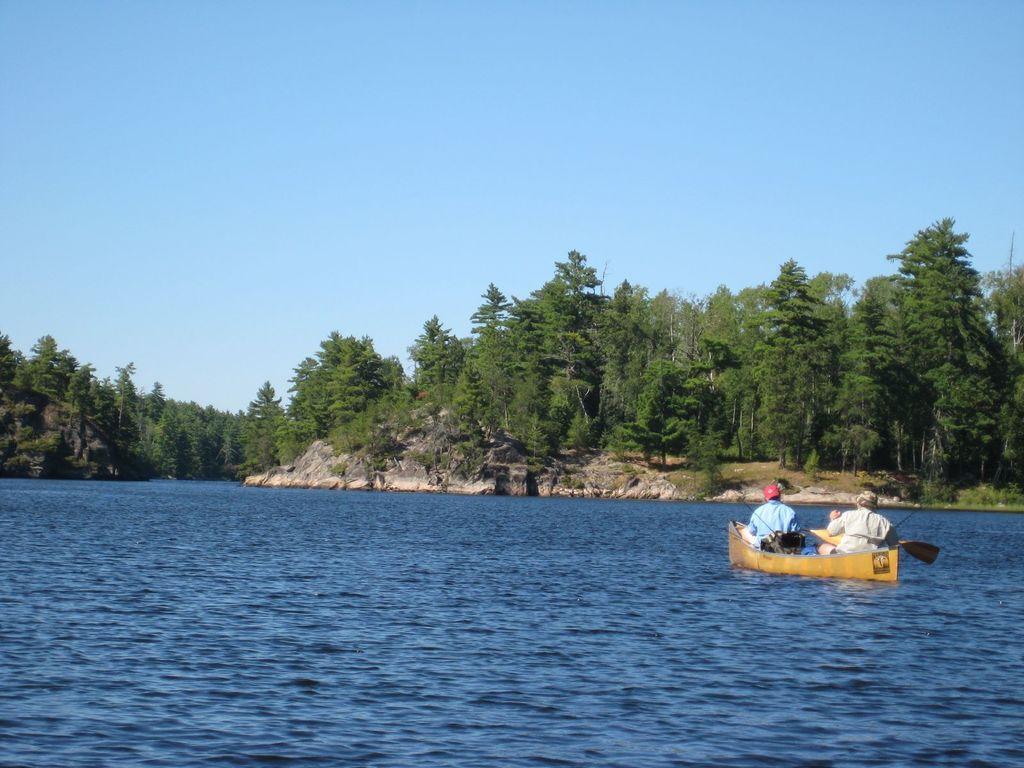Please provide a concise description of this image. In the image we can see the boat in the water, in the boat there are people sitting, wearing clothes and cap. Here we can see paddle, the hill, trees and the pale blue sky. 